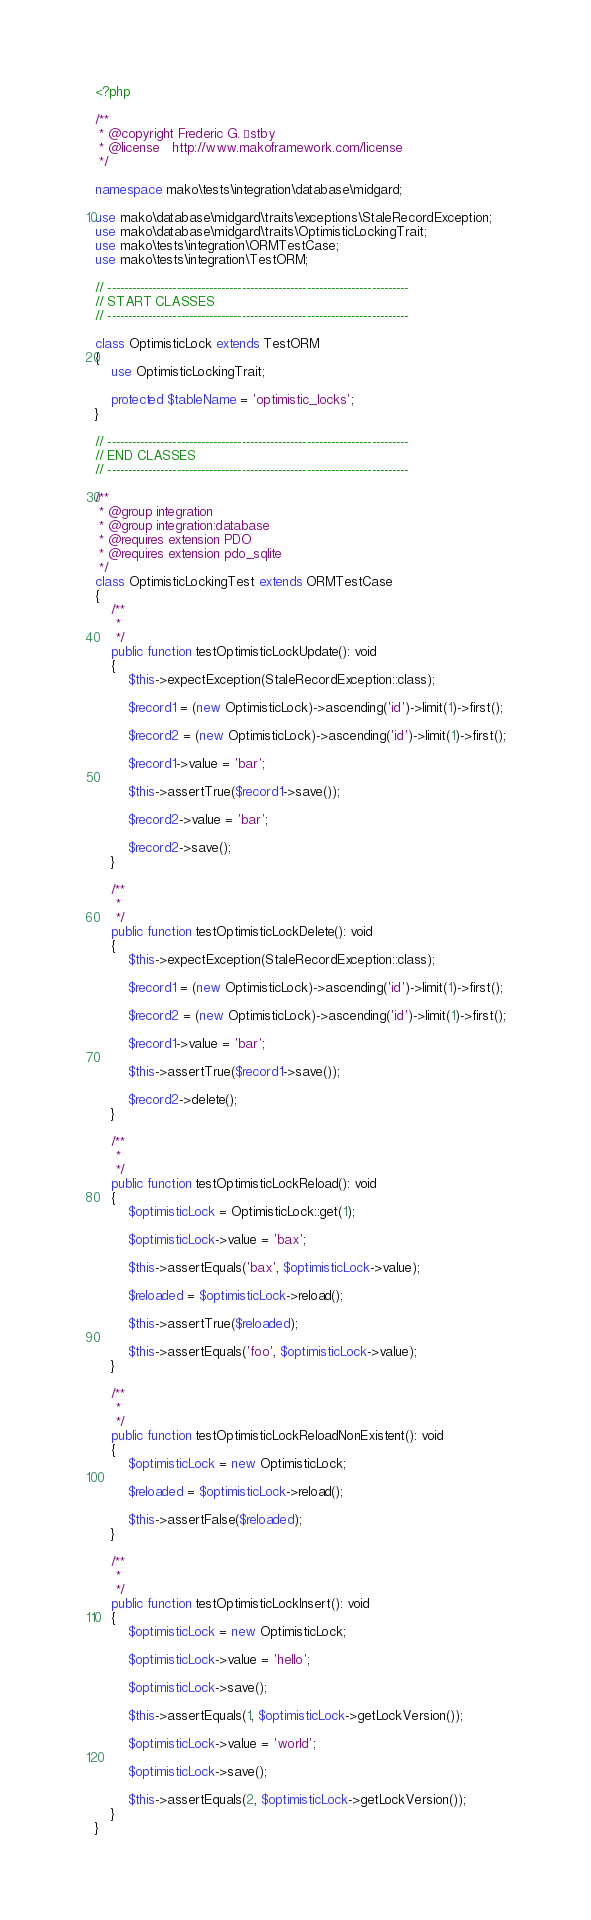Convert code to text. <code><loc_0><loc_0><loc_500><loc_500><_PHP_><?php

/**
 * @copyright Frederic G. Østby
 * @license   http://www.makoframework.com/license
 */

namespace mako\tests\integration\database\midgard;

use mako\database\midgard\traits\exceptions\StaleRecordException;
use mako\database\midgard\traits\OptimisticLockingTrait;
use mako\tests\integration\ORMTestCase;
use mako\tests\integration\TestORM;

// --------------------------------------------------------------------------
// START CLASSES
// --------------------------------------------------------------------------

class OptimisticLock extends TestORM
{
	use OptimisticLockingTrait;

	protected $tableName = 'optimistic_locks';
}

// --------------------------------------------------------------------------
// END CLASSES
// --------------------------------------------------------------------------

/**
 * @group integration
 * @group integration:database
 * @requires extension PDO
 * @requires extension pdo_sqlite
 */
class OptimisticLockingTest extends ORMTestCase
{
	/**
	 *
	 */
	public function testOptimisticLockUpdate(): void
	{
		$this->expectException(StaleRecordException::class);

		$record1 = (new OptimisticLock)->ascending('id')->limit(1)->first();

		$record2 = (new OptimisticLock)->ascending('id')->limit(1)->first();

		$record1->value = 'bar';

		$this->assertTrue($record1->save());

		$record2->value = 'bar';

		$record2->save();
	}

	/**
	 *
	 */
	public function testOptimisticLockDelete(): void
	{
		$this->expectException(StaleRecordException::class);

		$record1 = (new OptimisticLock)->ascending('id')->limit(1)->first();

		$record2 = (new OptimisticLock)->ascending('id')->limit(1)->first();

		$record1->value = 'bar';

		$this->assertTrue($record1->save());

		$record2->delete();
	}

	/**
	 *
	 */
	public function testOptimisticLockReload(): void
	{
		$optimisticLock = OptimisticLock::get(1);

		$optimisticLock->value = 'bax';

		$this->assertEquals('bax', $optimisticLock->value);

		$reloaded = $optimisticLock->reload();

		$this->assertTrue($reloaded);

		$this->assertEquals('foo', $optimisticLock->value);
	}

	/**
	 *
	 */
	public function testOptimisticLockReloadNonExistent(): void
	{
		$optimisticLock = new OptimisticLock;

		$reloaded = $optimisticLock->reload();

		$this->assertFalse($reloaded);
	}

	/**
	 *
	 */
	public function testOptimisticLockInsert(): void
	{
		$optimisticLock = new OptimisticLock;

		$optimisticLock->value = 'hello';

		$optimisticLock->save();

		$this->assertEquals(1, $optimisticLock->getLockVersion());

		$optimisticLock->value = 'world';

		$optimisticLock->save();

		$this->assertEquals(2, $optimisticLock->getLockVersion());
	}
}
</code> 